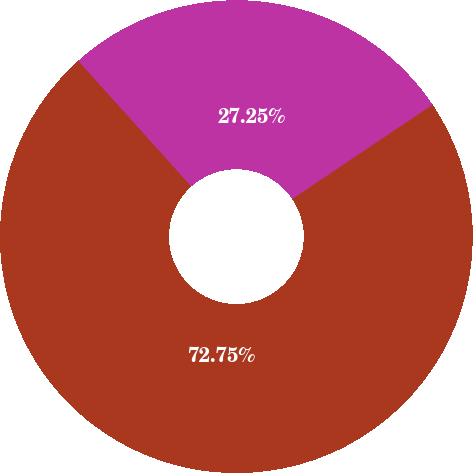<chart> <loc_0><loc_0><loc_500><loc_500><pie_chart><fcel>May 1 2011 to May 31 2011<fcel>June 1 2011 to June 30 2011<nl><fcel>27.25%<fcel>72.75%<nl></chart> 